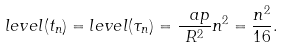<formula> <loc_0><loc_0><loc_500><loc_500>l e v e l ( t _ { n } ) = l e v e l ( \tau _ { n } ) = \frac { \ a p } { R ^ { 2 } } n ^ { 2 } = \frac { n ^ { 2 } } { 1 6 } .</formula> 